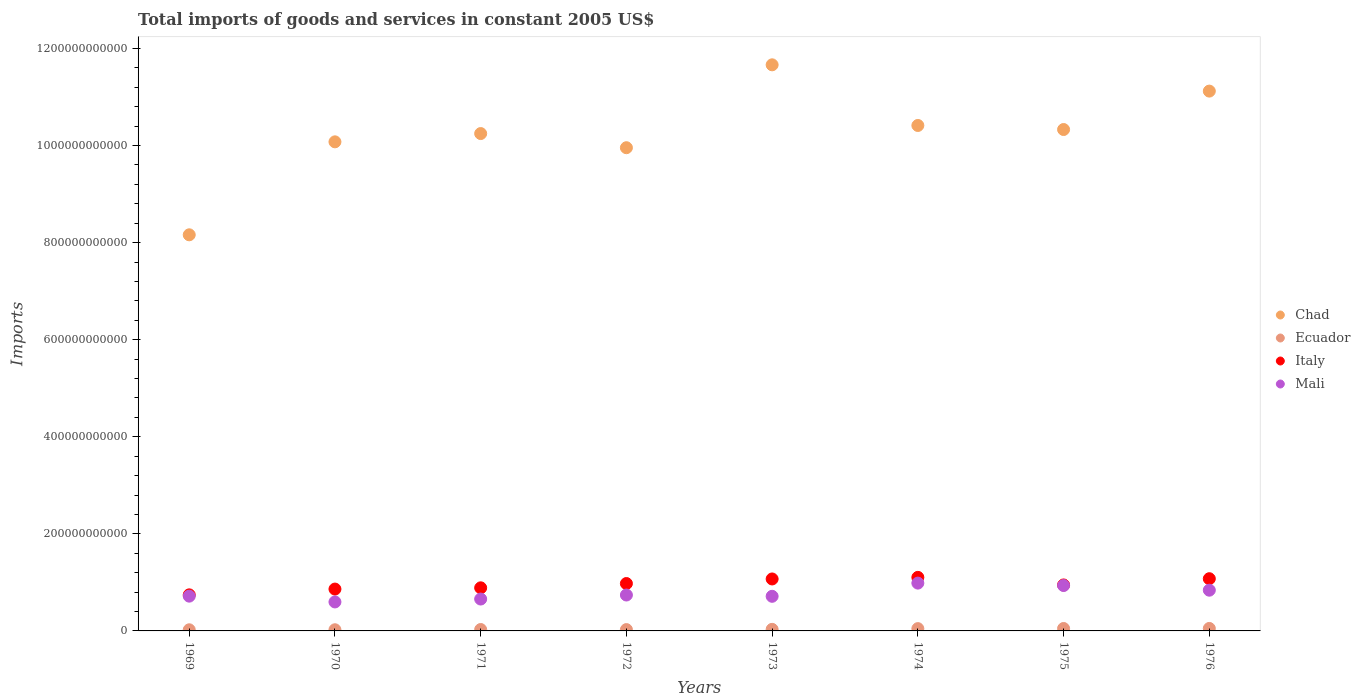How many different coloured dotlines are there?
Your answer should be very brief. 4. What is the total imports of goods and services in Italy in 1973?
Offer a very short reply. 1.07e+11. Across all years, what is the maximum total imports of goods and services in Ecuador?
Your answer should be compact. 5.10e+09. Across all years, what is the minimum total imports of goods and services in Mali?
Provide a short and direct response. 5.97e+1. In which year was the total imports of goods and services in Mali maximum?
Keep it short and to the point. 1974. In which year was the total imports of goods and services in Mali minimum?
Your response must be concise. 1970. What is the total total imports of goods and services in Italy in the graph?
Offer a very short reply. 7.67e+11. What is the difference between the total imports of goods and services in Ecuador in 1971 and that in 1972?
Provide a succinct answer. 1.66e+08. What is the difference between the total imports of goods and services in Chad in 1969 and the total imports of goods and services in Ecuador in 1976?
Your answer should be very brief. 8.11e+11. What is the average total imports of goods and services in Mali per year?
Your response must be concise. 7.73e+1. In the year 1975, what is the difference between the total imports of goods and services in Ecuador and total imports of goods and services in Italy?
Provide a short and direct response. -8.97e+1. In how many years, is the total imports of goods and services in Mali greater than 360000000000 US$?
Give a very brief answer. 0. What is the ratio of the total imports of goods and services in Chad in 1973 to that in 1974?
Your answer should be compact. 1.12. What is the difference between the highest and the second highest total imports of goods and services in Mali?
Ensure brevity in your answer.  4.97e+09. What is the difference between the highest and the lowest total imports of goods and services in Ecuador?
Keep it short and to the point. 2.77e+09. In how many years, is the total imports of goods and services in Ecuador greater than the average total imports of goods and services in Ecuador taken over all years?
Your response must be concise. 3. Is it the case that in every year, the sum of the total imports of goods and services in Italy and total imports of goods and services in Mali  is greater than the sum of total imports of goods and services in Ecuador and total imports of goods and services in Chad?
Your answer should be very brief. No. Is it the case that in every year, the sum of the total imports of goods and services in Mali and total imports of goods and services in Chad  is greater than the total imports of goods and services in Ecuador?
Give a very brief answer. Yes. Does the total imports of goods and services in Mali monotonically increase over the years?
Your response must be concise. No. Is the total imports of goods and services in Mali strictly greater than the total imports of goods and services in Italy over the years?
Your response must be concise. No. How many dotlines are there?
Ensure brevity in your answer.  4. How many years are there in the graph?
Provide a short and direct response. 8. What is the difference between two consecutive major ticks on the Y-axis?
Your response must be concise. 2.00e+11. Are the values on the major ticks of Y-axis written in scientific E-notation?
Ensure brevity in your answer.  No. Does the graph contain grids?
Offer a terse response. No. How are the legend labels stacked?
Provide a short and direct response. Vertical. What is the title of the graph?
Offer a terse response. Total imports of goods and services in constant 2005 US$. Does "Philippines" appear as one of the legend labels in the graph?
Your answer should be compact. No. What is the label or title of the Y-axis?
Ensure brevity in your answer.  Imports. What is the Imports of Chad in 1969?
Your answer should be very brief. 8.16e+11. What is the Imports of Ecuador in 1969?
Make the answer very short. 2.33e+09. What is the Imports of Italy in 1969?
Make the answer very short. 7.43e+1. What is the Imports in Mali in 1969?
Your answer should be very brief. 7.16e+1. What is the Imports of Chad in 1970?
Give a very brief answer. 1.01e+12. What is the Imports in Ecuador in 1970?
Your answer should be compact. 2.40e+09. What is the Imports of Italy in 1970?
Your answer should be very brief. 8.62e+1. What is the Imports in Mali in 1970?
Your answer should be compact. 5.97e+1. What is the Imports in Chad in 1971?
Your answer should be compact. 1.02e+12. What is the Imports in Ecuador in 1971?
Provide a short and direct response. 2.89e+09. What is the Imports in Italy in 1971?
Your answer should be very brief. 8.88e+1. What is the Imports in Mali in 1971?
Provide a short and direct response. 6.57e+1. What is the Imports in Chad in 1972?
Keep it short and to the point. 9.95e+11. What is the Imports in Ecuador in 1972?
Ensure brevity in your answer.  2.73e+09. What is the Imports in Italy in 1972?
Your response must be concise. 9.76e+1. What is the Imports in Mali in 1972?
Your response must be concise. 7.40e+1. What is the Imports of Chad in 1973?
Give a very brief answer. 1.17e+12. What is the Imports of Ecuador in 1973?
Ensure brevity in your answer.  3.23e+09. What is the Imports of Italy in 1973?
Provide a short and direct response. 1.07e+11. What is the Imports in Mali in 1973?
Make the answer very short. 7.13e+1. What is the Imports in Chad in 1974?
Keep it short and to the point. 1.04e+12. What is the Imports of Ecuador in 1974?
Keep it short and to the point. 4.74e+09. What is the Imports of Italy in 1974?
Your answer should be very brief. 1.10e+11. What is the Imports in Mali in 1974?
Your answer should be very brief. 9.85e+1. What is the Imports in Chad in 1975?
Give a very brief answer. 1.03e+12. What is the Imports of Ecuador in 1975?
Your answer should be very brief. 5.00e+09. What is the Imports in Italy in 1975?
Offer a terse response. 9.47e+1. What is the Imports of Mali in 1975?
Offer a terse response. 9.35e+1. What is the Imports in Chad in 1976?
Provide a succinct answer. 1.11e+12. What is the Imports in Ecuador in 1976?
Offer a very short reply. 5.10e+09. What is the Imports in Italy in 1976?
Your answer should be very brief. 1.08e+11. What is the Imports in Mali in 1976?
Ensure brevity in your answer.  8.39e+1. Across all years, what is the maximum Imports of Chad?
Make the answer very short. 1.17e+12. Across all years, what is the maximum Imports of Ecuador?
Ensure brevity in your answer.  5.10e+09. Across all years, what is the maximum Imports in Italy?
Provide a short and direct response. 1.10e+11. Across all years, what is the maximum Imports in Mali?
Give a very brief answer. 9.85e+1. Across all years, what is the minimum Imports of Chad?
Offer a very short reply. 8.16e+11. Across all years, what is the minimum Imports of Ecuador?
Ensure brevity in your answer.  2.33e+09. Across all years, what is the minimum Imports of Italy?
Provide a succinct answer. 7.43e+1. Across all years, what is the minimum Imports in Mali?
Your answer should be compact. 5.97e+1. What is the total Imports in Chad in the graph?
Give a very brief answer. 8.20e+12. What is the total Imports of Ecuador in the graph?
Your answer should be compact. 2.84e+1. What is the total Imports in Italy in the graph?
Your response must be concise. 7.67e+11. What is the total Imports of Mali in the graph?
Keep it short and to the point. 6.18e+11. What is the difference between the Imports of Chad in 1969 and that in 1970?
Provide a succinct answer. -1.92e+11. What is the difference between the Imports in Ecuador in 1969 and that in 1970?
Keep it short and to the point. -7.49e+07. What is the difference between the Imports of Italy in 1969 and that in 1970?
Give a very brief answer. -1.19e+1. What is the difference between the Imports of Mali in 1969 and that in 1970?
Offer a terse response. 1.19e+1. What is the difference between the Imports in Chad in 1969 and that in 1971?
Ensure brevity in your answer.  -2.09e+11. What is the difference between the Imports of Ecuador in 1969 and that in 1971?
Make the answer very short. -5.65e+08. What is the difference between the Imports of Italy in 1969 and that in 1971?
Offer a very short reply. -1.45e+1. What is the difference between the Imports of Mali in 1969 and that in 1971?
Give a very brief answer. 5.97e+09. What is the difference between the Imports in Chad in 1969 and that in 1972?
Give a very brief answer. -1.79e+11. What is the difference between the Imports of Ecuador in 1969 and that in 1972?
Ensure brevity in your answer.  -3.99e+08. What is the difference between the Imports in Italy in 1969 and that in 1972?
Provide a succinct answer. -2.33e+1. What is the difference between the Imports in Mali in 1969 and that in 1972?
Give a very brief answer. -2.32e+09. What is the difference between the Imports in Chad in 1969 and that in 1973?
Keep it short and to the point. -3.50e+11. What is the difference between the Imports in Ecuador in 1969 and that in 1973?
Give a very brief answer. -8.98e+08. What is the difference between the Imports of Italy in 1969 and that in 1973?
Your answer should be very brief. -3.27e+1. What is the difference between the Imports of Mali in 1969 and that in 1973?
Keep it short and to the point. 3.33e+08. What is the difference between the Imports in Chad in 1969 and that in 1974?
Offer a very short reply. -2.25e+11. What is the difference between the Imports in Ecuador in 1969 and that in 1974?
Provide a short and direct response. -2.41e+09. What is the difference between the Imports of Italy in 1969 and that in 1974?
Give a very brief answer. -3.60e+1. What is the difference between the Imports of Mali in 1969 and that in 1974?
Your response must be concise. -2.69e+1. What is the difference between the Imports of Chad in 1969 and that in 1975?
Ensure brevity in your answer.  -2.17e+11. What is the difference between the Imports of Ecuador in 1969 and that in 1975?
Offer a terse response. -2.67e+09. What is the difference between the Imports of Italy in 1969 and that in 1975?
Keep it short and to the point. -2.04e+1. What is the difference between the Imports of Mali in 1969 and that in 1975?
Your answer should be compact. -2.19e+1. What is the difference between the Imports in Chad in 1969 and that in 1976?
Offer a very short reply. -2.96e+11. What is the difference between the Imports in Ecuador in 1969 and that in 1976?
Your answer should be compact. -2.77e+09. What is the difference between the Imports of Italy in 1969 and that in 1976?
Offer a very short reply. -3.32e+1. What is the difference between the Imports of Mali in 1969 and that in 1976?
Your response must be concise. -1.23e+1. What is the difference between the Imports in Chad in 1970 and that in 1971?
Give a very brief answer. -1.70e+1. What is the difference between the Imports of Ecuador in 1970 and that in 1971?
Provide a succinct answer. -4.90e+08. What is the difference between the Imports in Italy in 1970 and that in 1971?
Make the answer very short. -2.57e+09. What is the difference between the Imports in Mali in 1970 and that in 1971?
Make the answer very short. -5.97e+09. What is the difference between the Imports of Chad in 1970 and that in 1972?
Offer a very short reply. 1.21e+1. What is the difference between the Imports of Ecuador in 1970 and that in 1972?
Ensure brevity in your answer.  -3.24e+08. What is the difference between the Imports in Italy in 1970 and that in 1972?
Offer a very short reply. -1.14e+1. What is the difference between the Imports in Mali in 1970 and that in 1972?
Provide a short and direct response. -1.43e+1. What is the difference between the Imports in Chad in 1970 and that in 1973?
Offer a very short reply. -1.59e+11. What is the difference between the Imports of Ecuador in 1970 and that in 1973?
Provide a succinct answer. -8.23e+08. What is the difference between the Imports in Italy in 1970 and that in 1973?
Your answer should be very brief. -2.08e+1. What is the difference between the Imports in Mali in 1970 and that in 1973?
Your answer should be very brief. -1.16e+1. What is the difference between the Imports of Chad in 1970 and that in 1974?
Your answer should be compact. -3.37e+1. What is the difference between the Imports of Ecuador in 1970 and that in 1974?
Provide a short and direct response. -2.34e+09. What is the difference between the Imports of Italy in 1970 and that in 1974?
Your response must be concise. -2.41e+1. What is the difference between the Imports of Mali in 1970 and that in 1974?
Ensure brevity in your answer.  -3.88e+1. What is the difference between the Imports of Chad in 1970 and that in 1975?
Your answer should be very brief. -2.54e+1. What is the difference between the Imports of Ecuador in 1970 and that in 1975?
Make the answer very short. -2.60e+09. What is the difference between the Imports of Italy in 1970 and that in 1975?
Your answer should be very brief. -8.49e+09. What is the difference between the Imports of Mali in 1970 and that in 1975?
Make the answer very short. -3.38e+1. What is the difference between the Imports in Chad in 1970 and that in 1976?
Provide a succinct answer. -1.05e+11. What is the difference between the Imports of Ecuador in 1970 and that in 1976?
Keep it short and to the point. -2.70e+09. What is the difference between the Imports in Italy in 1970 and that in 1976?
Keep it short and to the point. -2.13e+1. What is the difference between the Imports in Mali in 1970 and that in 1976?
Ensure brevity in your answer.  -2.42e+1. What is the difference between the Imports of Chad in 1971 and that in 1972?
Make the answer very short. 2.92e+1. What is the difference between the Imports in Ecuador in 1971 and that in 1972?
Provide a short and direct response. 1.66e+08. What is the difference between the Imports in Italy in 1971 and that in 1972?
Provide a short and direct response. -8.83e+09. What is the difference between the Imports of Mali in 1971 and that in 1972?
Your response must be concise. -8.29e+09. What is the difference between the Imports of Chad in 1971 and that in 1973?
Give a very brief answer. -1.42e+11. What is the difference between the Imports in Ecuador in 1971 and that in 1973?
Ensure brevity in your answer.  -3.33e+08. What is the difference between the Imports in Italy in 1971 and that in 1973?
Your answer should be very brief. -1.82e+1. What is the difference between the Imports in Mali in 1971 and that in 1973?
Make the answer very short. -5.64e+09. What is the difference between the Imports of Chad in 1971 and that in 1974?
Provide a short and direct response. -1.67e+1. What is the difference between the Imports of Ecuador in 1971 and that in 1974?
Your response must be concise. -1.85e+09. What is the difference between the Imports of Italy in 1971 and that in 1974?
Offer a terse response. -2.15e+1. What is the difference between the Imports in Mali in 1971 and that in 1974?
Make the answer very short. -3.28e+1. What is the difference between the Imports in Chad in 1971 and that in 1975?
Provide a short and direct response. -8.33e+09. What is the difference between the Imports in Ecuador in 1971 and that in 1975?
Ensure brevity in your answer.  -2.11e+09. What is the difference between the Imports in Italy in 1971 and that in 1975?
Give a very brief answer. -5.92e+09. What is the difference between the Imports in Mali in 1971 and that in 1975?
Your answer should be compact. -2.79e+1. What is the difference between the Imports in Chad in 1971 and that in 1976?
Your response must be concise. -8.75e+1. What is the difference between the Imports of Ecuador in 1971 and that in 1976?
Offer a very short reply. -2.21e+09. What is the difference between the Imports of Italy in 1971 and that in 1976?
Keep it short and to the point. -1.88e+1. What is the difference between the Imports in Mali in 1971 and that in 1976?
Your answer should be very brief. -1.82e+1. What is the difference between the Imports of Chad in 1972 and that in 1973?
Ensure brevity in your answer.  -1.71e+11. What is the difference between the Imports in Ecuador in 1972 and that in 1973?
Offer a terse response. -4.98e+08. What is the difference between the Imports in Italy in 1972 and that in 1973?
Provide a succinct answer. -9.42e+09. What is the difference between the Imports of Mali in 1972 and that in 1973?
Provide a short and direct response. 2.65e+09. What is the difference between the Imports in Chad in 1972 and that in 1974?
Keep it short and to the point. -4.58e+1. What is the difference between the Imports of Ecuador in 1972 and that in 1974?
Provide a short and direct response. -2.01e+09. What is the difference between the Imports in Italy in 1972 and that in 1974?
Your answer should be compact. -1.27e+1. What is the difference between the Imports of Mali in 1972 and that in 1974?
Offer a terse response. -2.45e+1. What is the difference between the Imports of Chad in 1972 and that in 1975?
Give a very brief answer. -3.75e+1. What is the difference between the Imports of Ecuador in 1972 and that in 1975?
Ensure brevity in your answer.  -2.27e+09. What is the difference between the Imports in Italy in 1972 and that in 1975?
Offer a terse response. 2.91e+09. What is the difference between the Imports of Mali in 1972 and that in 1975?
Offer a terse response. -1.96e+1. What is the difference between the Imports in Chad in 1972 and that in 1976?
Make the answer very short. -1.17e+11. What is the difference between the Imports in Ecuador in 1972 and that in 1976?
Keep it short and to the point. -2.37e+09. What is the difference between the Imports in Italy in 1972 and that in 1976?
Keep it short and to the point. -9.94e+09. What is the difference between the Imports in Mali in 1972 and that in 1976?
Your answer should be very brief. -9.95e+09. What is the difference between the Imports in Chad in 1973 and that in 1974?
Your response must be concise. 1.25e+11. What is the difference between the Imports in Ecuador in 1973 and that in 1974?
Provide a succinct answer. -1.51e+09. What is the difference between the Imports of Italy in 1973 and that in 1974?
Ensure brevity in your answer.  -3.29e+09. What is the difference between the Imports of Mali in 1973 and that in 1974?
Make the answer very short. -2.72e+1. What is the difference between the Imports in Chad in 1973 and that in 1975?
Your answer should be very brief. 1.33e+11. What is the difference between the Imports of Ecuador in 1973 and that in 1975?
Make the answer very short. -1.78e+09. What is the difference between the Imports of Italy in 1973 and that in 1975?
Make the answer very short. 1.23e+1. What is the difference between the Imports of Mali in 1973 and that in 1975?
Give a very brief answer. -2.22e+1. What is the difference between the Imports in Chad in 1973 and that in 1976?
Offer a very short reply. 5.41e+1. What is the difference between the Imports in Ecuador in 1973 and that in 1976?
Provide a short and direct response. -1.87e+09. What is the difference between the Imports in Italy in 1973 and that in 1976?
Your answer should be compact. -5.22e+08. What is the difference between the Imports of Mali in 1973 and that in 1976?
Ensure brevity in your answer.  -1.26e+1. What is the difference between the Imports in Chad in 1974 and that in 1975?
Provide a short and direct response. 8.34e+09. What is the difference between the Imports of Ecuador in 1974 and that in 1975?
Your answer should be very brief. -2.61e+08. What is the difference between the Imports in Italy in 1974 and that in 1975?
Provide a short and direct response. 1.56e+1. What is the difference between the Imports of Mali in 1974 and that in 1975?
Provide a succinct answer. 4.97e+09. What is the difference between the Imports in Chad in 1974 and that in 1976?
Your answer should be compact. -7.08e+1. What is the difference between the Imports in Ecuador in 1974 and that in 1976?
Make the answer very short. -3.61e+08. What is the difference between the Imports of Italy in 1974 and that in 1976?
Offer a terse response. 2.77e+09. What is the difference between the Imports of Mali in 1974 and that in 1976?
Your answer should be very brief. 1.46e+1. What is the difference between the Imports of Chad in 1975 and that in 1976?
Ensure brevity in your answer.  -7.91e+1. What is the difference between the Imports of Ecuador in 1975 and that in 1976?
Provide a succinct answer. -9.95e+07. What is the difference between the Imports in Italy in 1975 and that in 1976?
Provide a short and direct response. -1.28e+1. What is the difference between the Imports of Mali in 1975 and that in 1976?
Make the answer very short. 9.62e+09. What is the difference between the Imports in Chad in 1969 and the Imports in Ecuador in 1970?
Keep it short and to the point. 8.14e+11. What is the difference between the Imports of Chad in 1969 and the Imports of Italy in 1970?
Offer a very short reply. 7.30e+11. What is the difference between the Imports of Chad in 1969 and the Imports of Mali in 1970?
Provide a succinct answer. 7.56e+11. What is the difference between the Imports in Ecuador in 1969 and the Imports in Italy in 1970?
Provide a short and direct response. -8.39e+1. What is the difference between the Imports of Ecuador in 1969 and the Imports of Mali in 1970?
Provide a succinct answer. -5.74e+1. What is the difference between the Imports of Italy in 1969 and the Imports of Mali in 1970?
Ensure brevity in your answer.  1.46e+1. What is the difference between the Imports in Chad in 1969 and the Imports in Ecuador in 1971?
Keep it short and to the point. 8.13e+11. What is the difference between the Imports in Chad in 1969 and the Imports in Italy in 1971?
Your response must be concise. 7.27e+11. What is the difference between the Imports in Chad in 1969 and the Imports in Mali in 1971?
Provide a succinct answer. 7.50e+11. What is the difference between the Imports in Ecuador in 1969 and the Imports in Italy in 1971?
Keep it short and to the point. -8.65e+1. What is the difference between the Imports of Ecuador in 1969 and the Imports of Mali in 1971?
Give a very brief answer. -6.33e+1. What is the difference between the Imports in Italy in 1969 and the Imports in Mali in 1971?
Provide a short and direct response. 8.65e+09. What is the difference between the Imports in Chad in 1969 and the Imports in Ecuador in 1972?
Your response must be concise. 8.13e+11. What is the difference between the Imports in Chad in 1969 and the Imports in Italy in 1972?
Make the answer very short. 7.18e+11. What is the difference between the Imports of Chad in 1969 and the Imports of Mali in 1972?
Give a very brief answer. 7.42e+11. What is the difference between the Imports in Ecuador in 1969 and the Imports in Italy in 1972?
Your response must be concise. -9.53e+1. What is the difference between the Imports in Ecuador in 1969 and the Imports in Mali in 1972?
Your answer should be compact. -7.16e+1. What is the difference between the Imports of Italy in 1969 and the Imports of Mali in 1972?
Provide a succinct answer. 3.58e+08. What is the difference between the Imports of Chad in 1969 and the Imports of Ecuador in 1973?
Give a very brief answer. 8.13e+11. What is the difference between the Imports of Chad in 1969 and the Imports of Italy in 1973?
Your response must be concise. 7.09e+11. What is the difference between the Imports in Chad in 1969 and the Imports in Mali in 1973?
Your answer should be very brief. 7.45e+11. What is the difference between the Imports of Ecuador in 1969 and the Imports of Italy in 1973?
Make the answer very short. -1.05e+11. What is the difference between the Imports in Ecuador in 1969 and the Imports in Mali in 1973?
Your response must be concise. -6.90e+1. What is the difference between the Imports of Italy in 1969 and the Imports of Mali in 1973?
Ensure brevity in your answer.  3.01e+09. What is the difference between the Imports of Chad in 1969 and the Imports of Ecuador in 1974?
Your response must be concise. 8.11e+11. What is the difference between the Imports of Chad in 1969 and the Imports of Italy in 1974?
Provide a short and direct response. 7.06e+11. What is the difference between the Imports of Chad in 1969 and the Imports of Mali in 1974?
Your response must be concise. 7.18e+11. What is the difference between the Imports of Ecuador in 1969 and the Imports of Italy in 1974?
Keep it short and to the point. -1.08e+11. What is the difference between the Imports of Ecuador in 1969 and the Imports of Mali in 1974?
Your response must be concise. -9.62e+1. What is the difference between the Imports in Italy in 1969 and the Imports in Mali in 1974?
Ensure brevity in your answer.  -2.42e+1. What is the difference between the Imports of Chad in 1969 and the Imports of Ecuador in 1975?
Your answer should be very brief. 8.11e+11. What is the difference between the Imports in Chad in 1969 and the Imports in Italy in 1975?
Your answer should be compact. 7.21e+11. What is the difference between the Imports in Chad in 1969 and the Imports in Mali in 1975?
Keep it short and to the point. 7.23e+11. What is the difference between the Imports of Ecuador in 1969 and the Imports of Italy in 1975?
Make the answer very short. -9.24e+1. What is the difference between the Imports in Ecuador in 1969 and the Imports in Mali in 1975?
Provide a short and direct response. -9.12e+1. What is the difference between the Imports in Italy in 1969 and the Imports in Mali in 1975?
Your answer should be compact. -1.92e+1. What is the difference between the Imports in Chad in 1969 and the Imports in Ecuador in 1976?
Offer a very short reply. 8.11e+11. What is the difference between the Imports in Chad in 1969 and the Imports in Italy in 1976?
Provide a succinct answer. 7.09e+11. What is the difference between the Imports in Chad in 1969 and the Imports in Mali in 1976?
Your answer should be very brief. 7.32e+11. What is the difference between the Imports in Ecuador in 1969 and the Imports in Italy in 1976?
Provide a short and direct response. -1.05e+11. What is the difference between the Imports of Ecuador in 1969 and the Imports of Mali in 1976?
Offer a very short reply. -8.16e+1. What is the difference between the Imports in Italy in 1969 and the Imports in Mali in 1976?
Give a very brief answer. -9.59e+09. What is the difference between the Imports of Chad in 1970 and the Imports of Ecuador in 1971?
Ensure brevity in your answer.  1.00e+12. What is the difference between the Imports of Chad in 1970 and the Imports of Italy in 1971?
Give a very brief answer. 9.19e+11. What is the difference between the Imports in Chad in 1970 and the Imports in Mali in 1971?
Offer a terse response. 9.42e+11. What is the difference between the Imports of Ecuador in 1970 and the Imports of Italy in 1971?
Your answer should be compact. -8.64e+1. What is the difference between the Imports of Ecuador in 1970 and the Imports of Mali in 1971?
Give a very brief answer. -6.33e+1. What is the difference between the Imports of Italy in 1970 and the Imports of Mali in 1971?
Your answer should be compact. 2.05e+1. What is the difference between the Imports in Chad in 1970 and the Imports in Ecuador in 1972?
Your response must be concise. 1.00e+12. What is the difference between the Imports in Chad in 1970 and the Imports in Italy in 1972?
Make the answer very short. 9.10e+11. What is the difference between the Imports of Chad in 1970 and the Imports of Mali in 1972?
Offer a terse response. 9.34e+11. What is the difference between the Imports in Ecuador in 1970 and the Imports in Italy in 1972?
Your answer should be compact. -9.52e+1. What is the difference between the Imports in Ecuador in 1970 and the Imports in Mali in 1972?
Your answer should be compact. -7.16e+1. What is the difference between the Imports of Italy in 1970 and the Imports of Mali in 1972?
Keep it short and to the point. 1.23e+1. What is the difference between the Imports of Chad in 1970 and the Imports of Ecuador in 1973?
Keep it short and to the point. 1.00e+12. What is the difference between the Imports of Chad in 1970 and the Imports of Italy in 1973?
Keep it short and to the point. 9.01e+11. What is the difference between the Imports in Chad in 1970 and the Imports in Mali in 1973?
Your response must be concise. 9.36e+11. What is the difference between the Imports of Ecuador in 1970 and the Imports of Italy in 1973?
Keep it short and to the point. -1.05e+11. What is the difference between the Imports of Ecuador in 1970 and the Imports of Mali in 1973?
Your response must be concise. -6.89e+1. What is the difference between the Imports in Italy in 1970 and the Imports in Mali in 1973?
Give a very brief answer. 1.49e+1. What is the difference between the Imports in Chad in 1970 and the Imports in Ecuador in 1974?
Your answer should be compact. 1.00e+12. What is the difference between the Imports in Chad in 1970 and the Imports in Italy in 1974?
Provide a succinct answer. 8.97e+11. What is the difference between the Imports of Chad in 1970 and the Imports of Mali in 1974?
Offer a very short reply. 9.09e+11. What is the difference between the Imports of Ecuador in 1970 and the Imports of Italy in 1974?
Keep it short and to the point. -1.08e+11. What is the difference between the Imports in Ecuador in 1970 and the Imports in Mali in 1974?
Make the answer very short. -9.61e+1. What is the difference between the Imports of Italy in 1970 and the Imports of Mali in 1974?
Offer a very short reply. -1.23e+1. What is the difference between the Imports in Chad in 1970 and the Imports in Ecuador in 1975?
Keep it short and to the point. 1.00e+12. What is the difference between the Imports in Chad in 1970 and the Imports in Italy in 1975?
Provide a short and direct response. 9.13e+11. What is the difference between the Imports of Chad in 1970 and the Imports of Mali in 1975?
Make the answer very short. 9.14e+11. What is the difference between the Imports in Ecuador in 1970 and the Imports in Italy in 1975?
Make the answer very short. -9.23e+1. What is the difference between the Imports in Ecuador in 1970 and the Imports in Mali in 1975?
Make the answer very short. -9.11e+1. What is the difference between the Imports of Italy in 1970 and the Imports of Mali in 1975?
Offer a terse response. -7.31e+09. What is the difference between the Imports of Chad in 1970 and the Imports of Ecuador in 1976?
Make the answer very short. 1.00e+12. What is the difference between the Imports of Chad in 1970 and the Imports of Italy in 1976?
Your answer should be very brief. 9.00e+11. What is the difference between the Imports in Chad in 1970 and the Imports in Mali in 1976?
Your answer should be very brief. 9.24e+11. What is the difference between the Imports of Ecuador in 1970 and the Imports of Italy in 1976?
Provide a succinct answer. -1.05e+11. What is the difference between the Imports of Ecuador in 1970 and the Imports of Mali in 1976?
Make the answer very short. -8.15e+1. What is the difference between the Imports of Italy in 1970 and the Imports of Mali in 1976?
Your response must be concise. 2.31e+09. What is the difference between the Imports of Chad in 1971 and the Imports of Ecuador in 1972?
Offer a terse response. 1.02e+12. What is the difference between the Imports of Chad in 1971 and the Imports of Italy in 1972?
Offer a terse response. 9.27e+11. What is the difference between the Imports in Chad in 1971 and the Imports in Mali in 1972?
Provide a succinct answer. 9.51e+11. What is the difference between the Imports of Ecuador in 1971 and the Imports of Italy in 1972?
Ensure brevity in your answer.  -9.47e+1. What is the difference between the Imports of Ecuador in 1971 and the Imports of Mali in 1972?
Make the answer very short. -7.11e+1. What is the difference between the Imports in Italy in 1971 and the Imports in Mali in 1972?
Keep it short and to the point. 1.48e+1. What is the difference between the Imports of Chad in 1971 and the Imports of Ecuador in 1973?
Ensure brevity in your answer.  1.02e+12. What is the difference between the Imports in Chad in 1971 and the Imports in Italy in 1973?
Your answer should be compact. 9.18e+11. What is the difference between the Imports of Chad in 1971 and the Imports of Mali in 1973?
Your response must be concise. 9.53e+11. What is the difference between the Imports in Ecuador in 1971 and the Imports in Italy in 1973?
Give a very brief answer. -1.04e+11. What is the difference between the Imports in Ecuador in 1971 and the Imports in Mali in 1973?
Make the answer very short. -6.84e+1. What is the difference between the Imports in Italy in 1971 and the Imports in Mali in 1973?
Offer a terse response. 1.75e+1. What is the difference between the Imports of Chad in 1971 and the Imports of Ecuador in 1974?
Your answer should be very brief. 1.02e+12. What is the difference between the Imports of Chad in 1971 and the Imports of Italy in 1974?
Offer a terse response. 9.14e+11. What is the difference between the Imports of Chad in 1971 and the Imports of Mali in 1974?
Ensure brevity in your answer.  9.26e+11. What is the difference between the Imports of Ecuador in 1971 and the Imports of Italy in 1974?
Your response must be concise. -1.07e+11. What is the difference between the Imports of Ecuador in 1971 and the Imports of Mali in 1974?
Offer a terse response. -9.56e+1. What is the difference between the Imports of Italy in 1971 and the Imports of Mali in 1974?
Give a very brief answer. -9.71e+09. What is the difference between the Imports of Chad in 1971 and the Imports of Ecuador in 1975?
Make the answer very short. 1.02e+12. What is the difference between the Imports of Chad in 1971 and the Imports of Italy in 1975?
Keep it short and to the point. 9.30e+11. What is the difference between the Imports of Chad in 1971 and the Imports of Mali in 1975?
Your response must be concise. 9.31e+11. What is the difference between the Imports of Ecuador in 1971 and the Imports of Italy in 1975?
Give a very brief answer. -9.18e+1. What is the difference between the Imports of Ecuador in 1971 and the Imports of Mali in 1975?
Offer a very short reply. -9.06e+1. What is the difference between the Imports of Italy in 1971 and the Imports of Mali in 1975?
Keep it short and to the point. -4.74e+09. What is the difference between the Imports in Chad in 1971 and the Imports in Ecuador in 1976?
Your answer should be very brief. 1.02e+12. What is the difference between the Imports in Chad in 1971 and the Imports in Italy in 1976?
Your answer should be very brief. 9.17e+11. What is the difference between the Imports of Chad in 1971 and the Imports of Mali in 1976?
Offer a terse response. 9.41e+11. What is the difference between the Imports of Ecuador in 1971 and the Imports of Italy in 1976?
Keep it short and to the point. -1.05e+11. What is the difference between the Imports in Ecuador in 1971 and the Imports in Mali in 1976?
Your answer should be very brief. -8.10e+1. What is the difference between the Imports of Italy in 1971 and the Imports of Mali in 1976?
Ensure brevity in your answer.  4.88e+09. What is the difference between the Imports in Chad in 1972 and the Imports in Ecuador in 1973?
Your answer should be compact. 9.92e+11. What is the difference between the Imports of Chad in 1972 and the Imports of Italy in 1973?
Ensure brevity in your answer.  8.88e+11. What is the difference between the Imports of Chad in 1972 and the Imports of Mali in 1973?
Give a very brief answer. 9.24e+11. What is the difference between the Imports in Ecuador in 1972 and the Imports in Italy in 1973?
Offer a terse response. -1.04e+11. What is the difference between the Imports in Ecuador in 1972 and the Imports in Mali in 1973?
Your answer should be very brief. -6.86e+1. What is the difference between the Imports of Italy in 1972 and the Imports of Mali in 1973?
Keep it short and to the point. 2.63e+1. What is the difference between the Imports in Chad in 1972 and the Imports in Ecuador in 1974?
Provide a short and direct response. 9.91e+11. What is the difference between the Imports of Chad in 1972 and the Imports of Italy in 1974?
Keep it short and to the point. 8.85e+11. What is the difference between the Imports of Chad in 1972 and the Imports of Mali in 1974?
Ensure brevity in your answer.  8.97e+11. What is the difference between the Imports in Ecuador in 1972 and the Imports in Italy in 1974?
Keep it short and to the point. -1.08e+11. What is the difference between the Imports in Ecuador in 1972 and the Imports in Mali in 1974?
Offer a very short reply. -9.58e+1. What is the difference between the Imports in Italy in 1972 and the Imports in Mali in 1974?
Make the answer very short. -8.83e+08. What is the difference between the Imports in Chad in 1972 and the Imports in Ecuador in 1975?
Provide a short and direct response. 9.90e+11. What is the difference between the Imports of Chad in 1972 and the Imports of Italy in 1975?
Offer a terse response. 9.01e+11. What is the difference between the Imports of Chad in 1972 and the Imports of Mali in 1975?
Make the answer very short. 9.02e+11. What is the difference between the Imports of Ecuador in 1972 and the Imports of Italy in 1975?
Provide a succinct answer. -9.20e+1. What is the difference between the Imports of Ecuador in 1972 and the Imports of Mali in 1975?
Your response must be concise. -9.08e+1. What is the difference between the Imports of Italy in 1972 and the Imports of Mali in 1975?
Offer a terse response. 4.09e+09. What is the difference between the Imports in Chad in 1972 and the Imports in Ecuador in 1976?
Give a very brief answer. 9.90e+11. What is the difference between the Imports in Chad in 1972 and the Imports in Italy in 1976?
Make the answer very short. 8.88e+11. What is the difference between the Imports in Chad in 1972 and the Imports in Mali in 1976?
Keep it short and to the point. 9.12e+11. What is the difference between the Imports in Ecuador in 1972 and the Imports in Italy in 1976?
Your answer should be compact. -1.05e+11. What is the difference between the Imports of Ecuador in 1972 and the Imports of Mali in 1976?
Offer a very short reply. -8.12e+1. What is the difference between the Imports of Italy in 1972 and the Imports of Mali in 1976?
Your answer should be very brief. 1.37e+1. What is the difference between the Imports in Chad in 1973 and the Imports in Ecuador in 1974?
Your response must be concise. 1.16e+12. What is the difference between the Imports in Chad in 1973 and the Imports in Italy in 1974?
Provide a succinct answer. 1.06e+12. What is the difference between the Imports of Chad in 1973 and the Imports of Mali in 1974?
Your answer should be compact. 1.07e+12. What is the difference between the Imports of Ecuador in 1973 and the Imports of Italy in 1974?
Your response must be concise. -1.07e+11. What is the difference between the Imports in Ecuador in 1973 and the Imports in Mali in 1974?
Your answer should be compact. -9.53e+1. What is the difference between the Imports in Italy in 1973 and the Imports in Mali in 1974?
Give a very brief answer. 8.53e+09. What is the difference between the Imports in Chad in 1973 and the Imports in Ecuador in 1975?
Give a very brief answer. 1.16e+12. What is the difference between the Imports in Chad in 1973 and the Imports in Italy in 1975?
Offer a terse response. 1.07e+12. What is the difference between the Imports in Chad in 1973 and the Imports in Mali in 1975?
Ensure brevity in your answer.  1.07e+12. What is the difference between the Imports of Ecuador in 1973 and the Imports of Italy in 1975?
Keep it short and to the point. -9.15e+1. What is the difference between the Imports of Ecuador in 1973 and the Imports of Mali in 1975?
Ensure brevity in your answer.  -9.03e+1. What is the difference between the Imports of Italy in 1973 and the Imports of Mali in 1975?
Your response must be concise. 1.35e+1. What is the difference between the Imports of Chad in 1973 and the Imports of Ecuador in 1976?
Offer a very short reply. 1.16e+12. What is the difference between the Imports of Chad in 1973 and the Imports of Italy in 1976?
Make the answer very short. 1.06e+12. What is the difference between the Imports of Chad in 1973 and the Imports of Mali in 1976?
Provide a succinct answer. 1.08e+12. What is the difference between the Imports in Ecuador in 1973 and the Imports in Italy in 1976?
Provide a short and direct response. -1.04e+11. What is the difference between the Imports in Ecuador in 1973 and the Imports in Mali in 1976?
Offer a terse response. -8.07e+1. What is the difference between the Imports in Italy in 1973 and the Imports in Mali in 1976?
Ensure brevity in your answer.  2.31e+1. What is the difference between the Imports of Chad in 1974 and the Imports of Ecuador in 1975?
Provide a succinct answer. 1.04e+12. What is the difference between the Imports in Chad in 1974 and the Imports in Italy in 1975?
Provide a short and direct response. 9.47e+11. What is the difference between the Imports of Chad in 1974 and the Imports of Mali in 1975?
Make the answer very short. 9.48e+11. What is the difference between the Imports of Ecuador in 1974 and the Imports of Italy in 1975?
Provide a short and direct response. -9.00e+1. What is the difference between the Imports of Ecuador in 1974 and the Imports of Mali in 1975?
Provide a short and direct response. -8.88e+1. What is the difference between the Imports of Italy in 1974 and the Imports of Mali in 1975?
Provide a succinct answer. 1.68e+1. What is the difference between the Imports of Chad in 1974 and the Imports of Ecuador in 1976?
Your answer should be compact. 1.04e+12. What is the difference between the Imports of Chad in 1974 and the Imports of Italy in 1976?
Keep it short and to the point. 9.34e+11. What is the difference between the Imports in Chad in 1974 and the Imports in Mali in 1976?
Your answer should be compact. 9.57e+11. What is the difference between the Imports of Ecuador in 1974 and the Imports of Italy in 1976?
Give a very brief answer. -1.03e+11. What is the difference between the Imports in Ecuador in 1974 and the Imports in Mali in 1976?
Keep it short and to the point. -7.92e+1. What is the difference between the Imports of Italy in 1974 and the Imports of Mali in 1976?
Keep it short and to the point. 2.64e+1. What is the difference between the Imports in Chad in 1975 and the Imports in Ecuador in 1976?
Provide a succinct answer. 1.03e+12. What is the difference between the Imports of Chad in 1975 and the Imports of Italy in 1976?
Offer a terse response. 9.25e+11. What is the difference between the Imports of Chad in 1975 and the Imports of Mali in 1976?
Make the answer very short. 9.49e+11. What is the difference between the Imports of Ecuador in 1975 and the Imports of Italy in 1976?
Your response must be concise. -1.03e+11. What is the difference between the Imports in Ecuador in 1975 and the Imports in Mali in 1976?
Keep it short and to the point. -7.89e+1. What is the difference between the Imports in Italy in 1975 and the Imports in Mali in 1976?
Offer a very short reply. 1.08e+1. What is the average Imports of Chad per year?
Offer a terse response. 1.02e+12. What is the average Imports in Ecuador per year?
Provide a short and direct response. 3.55e+09. What is the average Imports of Italy per year?
Give a very brief answer. 9.58e+1. What is the average Imports of Mali per year?
Give a very brief answer. 7.73e+1. In the year 1969, what is the difference between the Imports in Chad and Imports in Ecuador?
Your answer should be very brief. 8.14e+11. In the year 1969, what is the difference between the Imports of Chad and Imports of Italy?
Provide a succinct answer. 7.42e+11. In the year 1969, what is the difference between the Imports of Chad and Imports of Mali?
Ensure brevity in your answer.  7.44e+11. In the year 1969, what is the difference between the Imports in Ecuador and Imports in Italy?
Your response must be concise. -7.20e+1. In the year 1969, what is the difference between the Imports in Ecuador and Imports in Mali?
Keep it short and to the point. -6.93e+1. In the year 1969, what is the difference between the Imports of Italy and Imports of Mali?
Offer a terse response. 2.68e+09. In the year 1970, what is the difference between the Imports of Chad and Imports of Ecuador?
Provide a short and direct response. 1.01e+12. In the year 1970, what is the difference between the Imports in Chad and Imports in Italy?
Offer a very short reply. 9.21e+11. In the year 1970, what is the difference between the Imports in Chad and Imports in Mali?
Provide a succinct answer. 9.48e+11. In the year 1970, what is the difference between the Imports in Ecuador and Imports in Italy?
Offer a terse response. -8.38e+1. In the year 1970, what is the difference between the Imports in Ecuador and Imports in Mali?
Make the answer very short. -5.73e+1. In the year 1970, what is the difference between the Imports in Italy and Imports in Mali?
Offer a terse response. 2.65e+1. In the year 1971, what is the difference between the Imports in Chad and Imports in Ecuador?
Ensure brevity in your answer.  1.02e+12. In the year 1971, what is the difference between the Imports of Chad and Imports of Italy?
Make the answer very short. 9.36e+11. In the year 1971, what is the difference between the Imports in Chad and Imports in Mali?
Offer a very short reply. 9.59e+11. In the year 1971, what is the difference between the Imports in Ecuador and Imports in Italy?
Your answer should be compact. -8.59e+1. In the year 1971, what is the difference between the Imports in Ecuador and Imports in Mali?
Your response must be concise. -6.28e+1. In the year 1971, what is the difference between the Imports in Italy and Imports in Mali?
Keep it short and to the point. 2.31e+1. In the year 1972, what is the difference between the Imports in Chad and Imports in Ecuador?
Ensure brevity in your answer.  9.93e+11. In the year 1972, what is the difference between the Imports in Chad and Imports in Italy?
Give a very brief answer. 8.98e+11. In the year 1972, what is the difference between the Imports in Chad and Imports in Mali?
Provide a succinct answer. 9.22e+11. In the year 1972, what is the difference between the Imports in Ecuador and Imports in Italy?
Offer a terse response. -9.49e+1. In the year 1972, what is the difference between the Imports of Ecuador and Imports of Mali?
Your answer should be compact. -7.12e+1. In the year 1972, what is the difference between the Imports of Italy and Imports of Mali?
Give a very brief answer. 2.37e+1. In the year 1973, what is the difference between the Imports in Chad and Imports in Ecuador?
Provide a short and direct response. 1.16e+12. In the year 1973, what is the difference between the Imports in Chad and Imports in Italy?
Give a very brief answer. 1.06e+12. In the year 1973, what is the difference between the Imports of Chad and Imports of Mali?
Provide a succinct answer. 1.09e+12. In the year 1973, what is the difference between the Imports in Ecuador and Imports in Italy?
Your answer should be very brief. -1.04e+11. In the year 1973, what is the difference between the Imports in Ecuador and Imports in Mali?
Keep it short and to the point. -6.81e+1. In the year 1973, what is the difference between the Imports of Italy and Imports of Mali?
Provide a succinct answer. 3.57e+1. In the year 1974, what is the difference between the Imports in Chad and Imports in Ecuador?
Keep it short and to the point. 1.04e+12. In the year 1974, what is the difference between the Imports of Chad and Imports of Italy?
Offer a terse response. 9.31e+11. In the year 1974, what is the difference between the Imports in Chad and Imports in Mali?
Keep it short and to the point. 9.43e+11. In the year 1974, what is the difference between the Imports of Ecuador and Imports of Italy?
Keep it short and to the point. -1.06e+11. In the year 1974, what is the difference between the Imports in Ecuador and Imports in Mali?
Provide a succinct answer. -9.38e+1. In the year 1974, what is the difference between the Imports in Italy and Imports in Mali?
Offer a very short reply. 1.18e+1. In the year 1975, what is the difference between the Imports of Chad and Imports of Ecuador?
Your answer should be compact. 1.03e+12. In the year 1975, what is the difference between the Imports of Chad and Imports of Italy?
Offer a very short reply. 9.38e+11. In the year 1975, what is the difference between the Imports of Chad and Imports of Mali?
Your answer should be very brief. 9.39e+11. In the year 1975, what is the difference between the Imports in Ecuador and Imports in Italy?
Provide a succinct answer. -8.97e+1. In the year 1975, what is the difference between the Imports in Ecuador and Imports in Mali?
Make the answer very short. -8.85e+1. In the year 1975, what is the difference between the Imports of Italy and Imports of Mali?
Provide a short and direct response. 1.18e+09. In the year 1976, what is the difference between the Imports in Chad and Imports in Ecuador?
Your response must be concise. 1.11e+12. In the year 1976, what is the difference between the Imports in Chad and Imports in Italy?
Make the answer very short. 1.00e+12. In the year 1976, what is the difference between the Imports of Chad and Imports of Mali?
Provide a short and direct response. 1.03e+12. In the year 1976, what is the difference between the Imports of Ecuador and Imports of Italy?
Make the answer very short. -1.02e+11. In the year 1976, what is the difference between the Imports in Ecuador and Imports in Mali?
Offer a terse response. -7.88e+1. In the year 1976, what is the difference between the Imports in Italy and Imports in Mali?
Give a very brief answer. 2.37e+1. What is the ratio of the Imports in Chad in 1969 to that in 1970?
Provide a succinct answer. 0.81. What is the ratio of the Imports of Ecuador in 1969 to that in 1970?
Give a very brief answer. 0.97. What is the ratio of the Imports in Italy in 1969 to that in 1970?
Your answer should be very brief. 0.86. What is the ratio of the Imports in Chad in 1969 to that in 1971?
Ensure brevity in your answer.  0.8. What is the ratio of the Imports of Ecuador in 1969 to that in 1971?
Your answer should be compact. 0.8. What is the ratio of the Imports of Italy in 1969 to that in 1971?
Offer a terse response. 0.84. What is the ratio of the Imports in Mali in 1969 to that in 1971?
Ensure brevity in your answer.  1.09. What is the ratio of the Imports in Chad in 1969 to that in 1972?
Offer a very short reply. 0.82. What is the ratio of the Imports in Ecuador in 1969 to that in 1972?
Your answer should be compact. 0.85. What is the ratio of the Imports in Italy in 1969 to that in 1972?
Offer a terse response. 0.76. What is the ratio of the Imports in Mali in 1969 to that in 1972?
Give a very brief answer. 0.97. What is the ratio of the Imports in Chad in 1969 to that in 1973?
Offer a very short reply. 0.7. What is the ratio of the Imports in Ecuador in 1969 to that in 1973?
Your answer should be very brief. 0.72. What is the ratio of the Imports in Italy in 1969 to that in 1973?
Offer a terse response. 0.69. What is the ratio of the Imports in Mali in 1969 to that in 1973?
Ensure brevity in your answer.  1. What is the ratio of the Imports in Chad in 1969 to that in 1974?
Make the answer very short. 0.78. What is the ratio of the Imports of Ecuador in 1969 to that in 1974?
Your answer should be compact. 0.49. What is the ratio of the Imports in Italy in 1969 to that in 1974?
Your response must be concise. 0.67. What is the ratio of the Imports in Mali in 1969 to that in 1974?
Your response must be concise. 0.73. What is the ratio of the Imports of Chad in 1969 to that in 1975?
Give a very brief answer. 0.79. What is the ratio of the Imports in Ecuador in 1969 to that in 1975?
Offer a terse response. 0.47. What is the ratio of the Imports of Italy in 1969 to that in 1975?
Offer a terse response. 0.78. What is the ratio of the Imports in Mali in 1969 to that in 1975?
Your answer should be very brief. 0.77. What is the ratio of the Imports in Chad in 1969 to that in 1976?
Keep it short and to the point. 0.73. What is the ratio of the Imports of Ecuador in 1969 to that in 1976?
Ensure brevity in your answer.  0.46. What is the ratio of the Imports of Italy in 1969 to that in 1976?
Your answer should be compact. 0.69. What is the ratio of the Imports of Mali in 1969 to that in 1976?
Offer a very short reply. 0.85. What is the ratio of the Imports in Chad in 1970 to that in 1971?
Provide a short and direct response. 0.98. What is the ratio of the Imports in Ecuador in 1970 to that in 1971?
Offer a very short reply. 0.83. What is the ratio of the Imports of Mali in 1970 to that in 1971?
Provide a succinct answer. 0.91. What is the ratio of the Imports of Chad in 1970 to that in 1972?
Make the answer very short. 1.01. What is the ratio of the Imports in Ecuador in 1970 to that in 1972?
Your answer should be very brief. 0.88. What is the ratio of the Imports in Italy in 1970 to that in 1972?
Offer a very short reply. 0.88. What is the ratio of the Imports in Mali in 1970 to that in 1972?
Your response must be concise. 0.81. What is the ratio of the Imports in Chad in 1970 to that in 1973?
Make the answer very short. 0.86. What is the ratio of the Imports of Ecuador in 1970 to that in 1973?
Your answer should be compact. 0.74. What is the ratio of the Imports in Italy in 1970 to that in 1973?
Your answer should be compact. 0.81. What is the ratio of the Imports in Mali in 1970 to that in 1973?
Offer a terse response. 0.84. What is the ratio of the Imports in Chad in 1970 to that in 1974?
Ensure brevity in your answer.  0.97. What is the ratio of the Imports in Ecuador in 1970 to that in 1974?
Keep it short and to the point. 0.51. What is the ratio of the Imports of Italy in 1970 to that in 1974?
Provide a short and direct response. 0.78. What is the ratio of the Imports in Mali in 1970 to that in 1974?
Offer a very short reply. 0.61. What is the ratio of the Imports of Chad in 1970 to that in 1975?
Give a very brief answer. 0.98. What is the ratio of the Imports in Ecuador in 1970 to that in 1975?
Your answer should be compact. 0.48. What is the ratio of the Imports of Italy in 1970 to that in 1975?
Offer a terse response. 0.91. What is the ratio of the Imports of Mali in 1970 to that in 1975?
Provide a succinct answer. 0.64. What is the ratio of the Imports in Chad in 1970 to that in 1976?
Provide a short and direct response. 0.91. What is the ratio of the Imports in Ecuador in 1970 to that in 1976?
Ensure brevity in your answer.  0.47. What is the ratio of the Imports in Italy in 1970 to that in 1976?
Your answer should be very brief. 0.8. What is the ratio of the Imports of Mali in 1970 to that in 1976?
Your response must be concise. 0.71. What is the ratio of the Imports of Chad in 1971 to that in 1972?
Your answer should be very brief. 1.03. What is the ratio of the Imports in Ecuador in 1971 to that in 1972?
Offer a very short reply. 1.06. What is the ratio of the Imports of Italy in 1971 to that in 1972?
Your answer should be compact. 0.91. What is the ratio of the Imports in Mali in 1971 to that in 1972?
Provide a succinct answer. 0.89. What is the ratio of the Imports of Chad in 1971 to that in 1973?
Provide a succinct answer. 0.88. What is the ratio of the Imports of Ecuador in 1971 to that in 1973?
Your answer should be very brief. 0.9. What is the ratio of the Imports in Italy in 1971 to that in 1973?
Provide a short and direct response. 0.83. What is the ratio of the Imports in Mali in 1971 to that in 1973?
Provide a succinct answer. 0.92. What is the ratio of the Imports in Chad in 1971 to that in 1974?
Keep it short and to the point. 0.98. What is the ratio of the Imports of Ecuador in 1971 to that in 1974?
Your response must be concise. 0.61. What is the ratio of the Imports of Italy in 1971 to that in 1974?
Your answer should be very brief. 0.8. What is the ratio of the Imports in Mali in 1971 to that in 1974?
Keep it short and to the point. 0.67. What is the ratio of the Imports of Chad in 1971 to that in 1975?
Your response must be concise. 0.99. What is the ratio of the Imports in Ecuador in 1971 to that in 1975?
Your response must be concise. 0.58. What is the ratio of the Imports of Italy in 1971 to that in 1975?
Give a very brief answer. 0.94. What is the ratio of the Imports in Mali in 1971 to that in 1975?
Offer a very short reply. 0.7. What is the ratio of the Imports in Chad in 1971 to that in 1976?
Your answer should be very brief. 0.92. What is the ratio of the Imports in Ecuador in 1971 to that in 1976?
Provide a short and direct response. 0.57. What is the ratio of the Imports in Italy in 1971 to that in 1976?
Provide a succinct answer. 0.83. What is the ratio of the Imports in Mali in 1971 to that in 1976?
Give a very brief answer. 0.78. What is the ratio of the Imports of Chad in 1972 to that in 1973?
Make the answer very short. 0.85. What is the ratio of the Imports in Ecuador in 1972 to that in 1973?
Your answer should be very brief. 0.85. What is the ratio of the Imports in Italy in 1972 to that in 1973?
Keep it short and to the point. 0.91. What is the ratio of the Imports in Mali in 1972 to that in 1973?
Offer a very short reply. 1.04. What is the ratio of the Imports in Chad in 1972 to that in 1974?
Your response must be concise. 0.96. What is the ratio of the Imports of Ecuador in 1972 to that in 1974?
Your answer should be compact. 0.58. What is the ratio of the Imports of Italy in 1972 to that in 1974?
Your response must be concise. 0.88. What is the ratio of the Imports in Mali in 1972 to that in 1974?
Keep it short and to the point. 0.75. What is the ratio of the Imports of Chad in 1972 to that in 1975?
Give a very brief answer. 0.96. What is the ratio of the Imports in Ecuador in 1972 to that in 1975?
Your answer should be compact. 0.55. What is the ratio of the Imports of Italy in 1972 to that in 1975?
Ensure brevity in your answer.  1.03. What is the ratio of the Imports in Mali in 1972 to that in 1975?
Your answer should be very brief. 0.79. What is the ratio of the Imports in Chad in 1972 to that in 1976?
Make the answer very short. 0.9. What is the ratio of the Imports in Ecuador in 1972 to that in 1976?
Offer a terse response. 0.53. What is the ratio of the Imports of Italy in 1972 to that in 1976?
Offer a terse response. 0.91. What is the ratio of the Imports of Mali in 1972 to that in 1976?
Ensure brevity in your answer.  0.88. What is the ratio of the Imports of Chad in 1973 to that in 1974?
Make the answer very short. 1.12. What is the ratio of the Imports of Ecuador in 1973 to that in 1974?
Your answer should be compact. 0.68. What is the ratio of the Imports of Italy in 1973 to that in 1974?
Offer a terse response. 0.97. What is the ratio of the Imports in Mali in 1973 to that in 1974?
Ensure brevity in your answer.  0.72. What is the ratio of the Imports of Chad in 1973 to that in 1975?
Keep it short and to the point. 1.13. What is the ratio of the Imports in Ecuador in 1973 to that in 1975?
Provide a succinct answer. 0.65. What is the ratio of the Imports of Italy in 1973 to that in 1975?
Provide a short and direct response. 1.13. What is the ratio of the Imports of Mali in 1973 to that in 1975?
Provide a short and direct response. 0.76. What is the ratio of the Imports of Chad in 1973 to that in 1976?
Your answer should be very brief. 1.05. What is the ratio of the Imports of Ecuador in 1973 to that in 1976?
Ensure brevity in your answer.  0.63. What is the ratio of the Imports of Italy in 1973 to that in 1976?
Offer a terse response. 1. What is the ratio of the Imports of Mali in 1973 to that in 1976?
Make the answer very short. 0.85. What is the ratio of the Imports of Chad in 1974 to that in 1975?
Provide a short and direct response. 1.01. What is the ratio of the Imports in Ecuador in 1974 to that in 1975?
Your answer should be very brief. 0.95. What is the ratio of the Imports of Italy in 1974 to that in 1975?
Offer a terse response. 1.16. What is the ratio of the Imports in Mali in 1974 to that in 1975?
Offer a very short reply. 1.05. What is the ratio of the Imports in Chad in 1974 to that in 1976?
Offer a very short reply. 0.94. What is the ratio of the Imports of Ecuador in 1974 to that in 1976?
Provide a short and direct response. 0.93. What is the ratio of the Imports in Italy in 1974 to that in 1976?
Your answer should be very brief. 1.03. What is the ratio of the Imports in Mali in 1974 to that in 1976?
Offer a very short reply. 1.17. What is the ratio of the Imports in Chad in 1975 to that in 1976?
Provide a succinct answer. 0.93. What is the ratio of the Imports in Ecuador in 1975 to that in 1976?
Your answer should be compact. 0.98. What is the ratio of the Imports of Italy in 1975 to that in 1976?
Offer a terse response. 0.88. What is the ratio of the Imports of Mali in 1975 to that in 1976?
Offer a very short reply. 1.11. What is the difference between the highest and the second highest Imports in Chad?
Provide a short and direct response. 5.41e+1. What is the difference between the highest and the second highest Imports in Ecuador?
Your response must be concise. 9.95e+07. What is the difference between the highest and the second highest Imports in Italy?
Provide a succinct answer. 2.77e+09. What is the difference between the highest and the second highest Imports of Mali?
Provide a succinct answer. 4.97e+09. What is the difference between the highest and the lowest Imports in Chad?
Your answer should be compact. 3.50e+11. What is the difference between the highest and the lowest Imports in Ecuador?
Offer a very short reply. 2.77e+09. What is the difference between the highest and the lowest Imports in Italy?
Your answer should be very brief. 3.60e+1. What is the difference between the highest and the lowest Imports of Mali?
Give a very brief answer. 3.88e+1. 